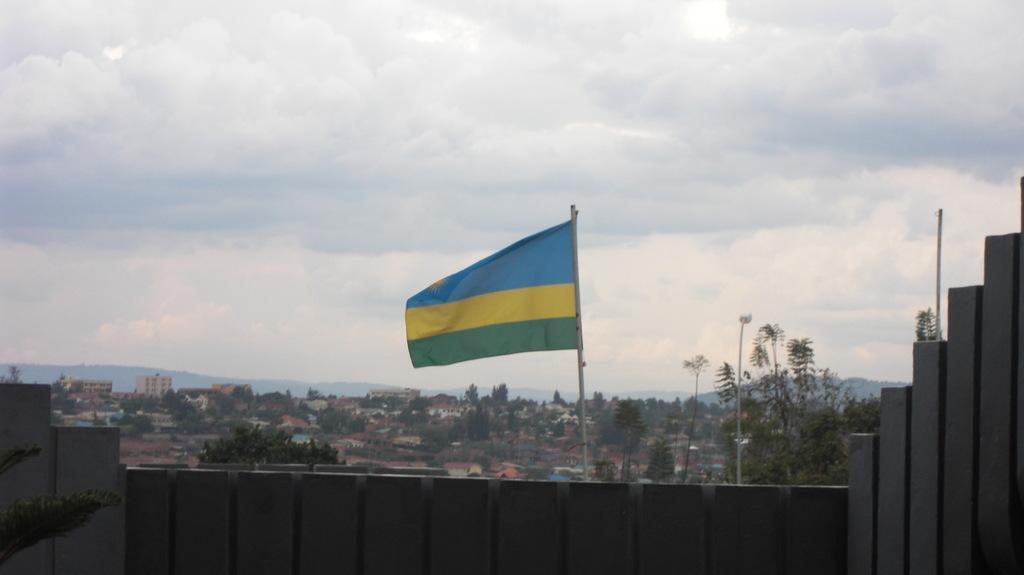Could you give a brief overview of what you see in this image? In this picture I can see the flag. I can see trees. I can see the buildings. I can see clouds in the sky. 